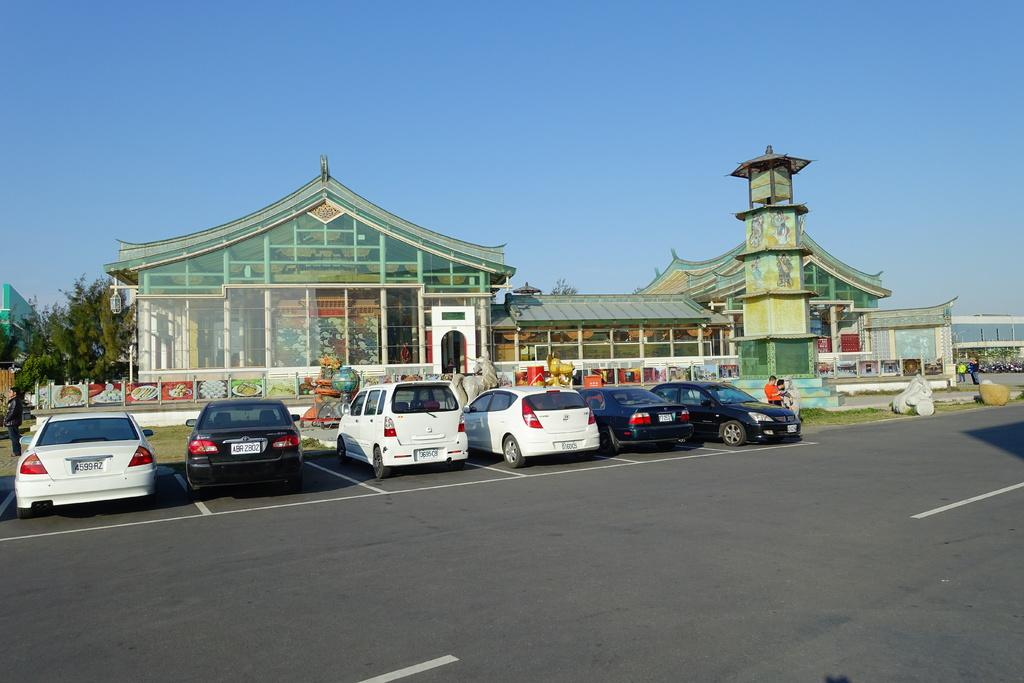What type of vehicles can be seen on the road in the image? There are cars on the road in the image. What else can be seen in the background of the image besides the road? There are people, buildings, and trees visible in the background of the image. What is located on the right side of the image? There are rocks on the right side of the image. What type of juice is being served at the government's birthday celebration in the image? There is no juice, government, or birthday celebration present in the image. 